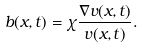Convert formula to latex. <formula><loc_0><loc_0><loc_500><loc_500>b ( x , t ) = \chi \frac { \nabla v ( x , t ) } { v ( x , t ) } .</formula> 